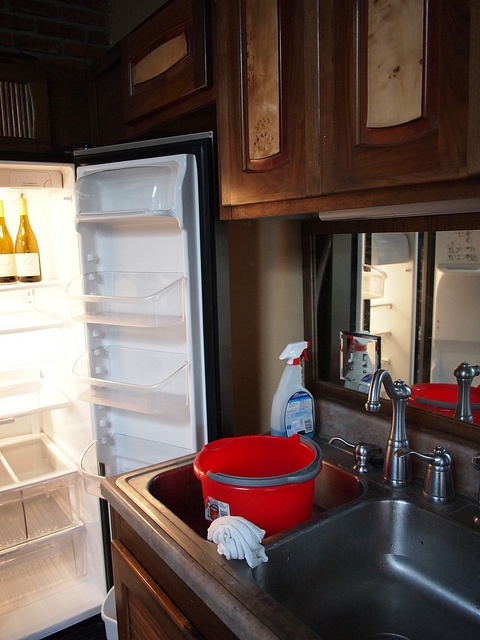Describe the objects in this image and their specific colors. I can see refrigerator in black, lightgray, darkgray, and tan tones, sink in black, brown, gray, and maroon tones, bottle in black, darkgray, and gray tones, bottle in black, orange, ivory, and gold tones, and bottle in black, orange, lightyellow, and khaki tones in this image. 